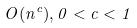Convert formula to latex. <formula><loc_0><loc_0><loc_500><loc_500>O ( n ^ { c } ) , 0 < c < 1</formula> 